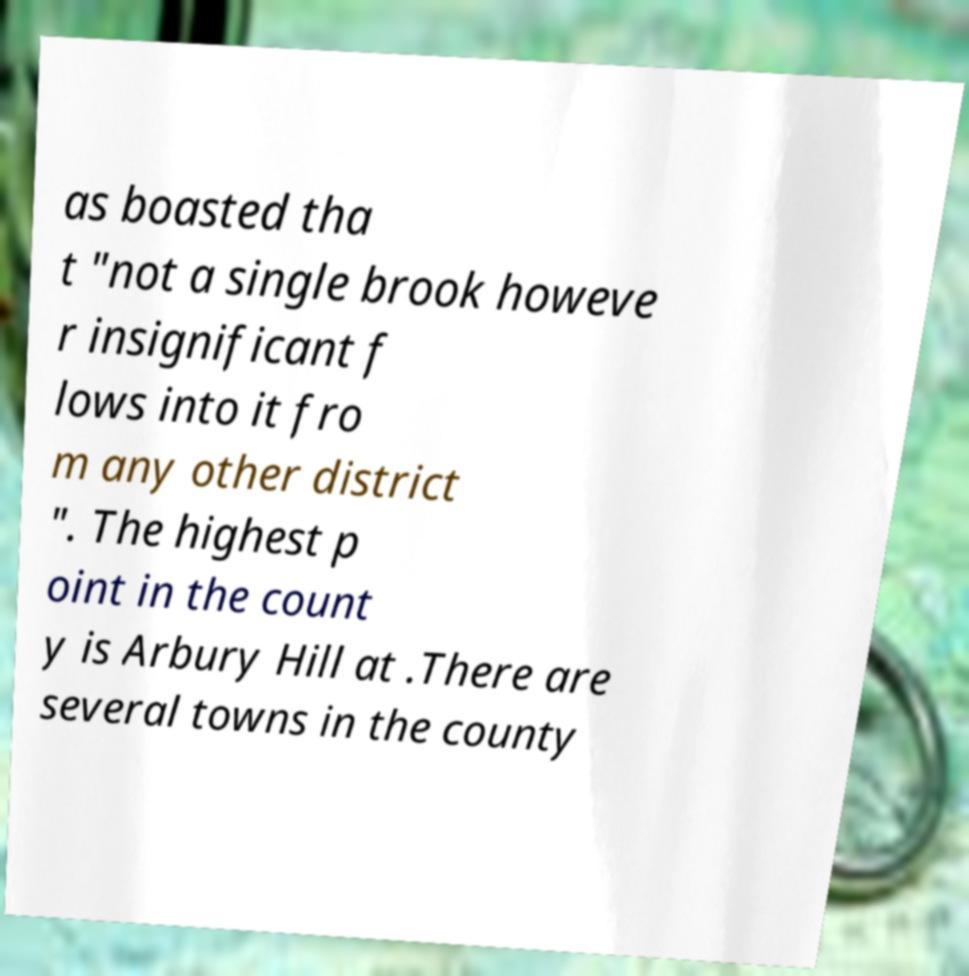Please identify and transcribe the text found in this image. as boasted tha t "not a single brook howeve r insignificant f lows into it fro m any other district ". The highest p oint in the count y is Arbury Hill at .There are several towns in the county 